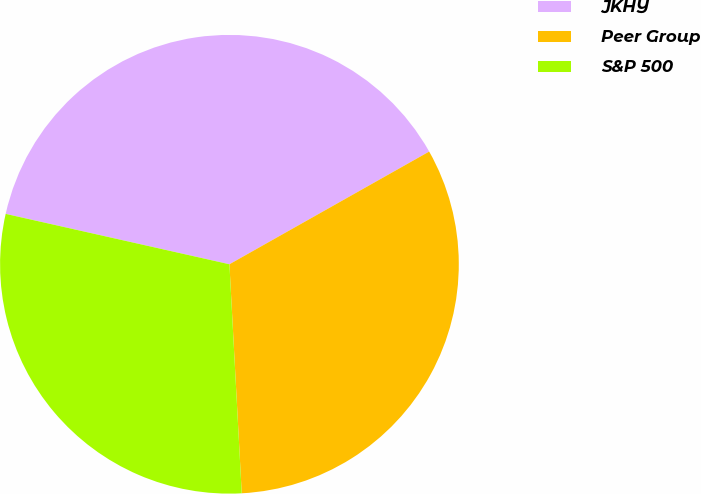Convert chart to OTSL. <chart><loc_0><loc_0><loc_500><loc_500><pie_chart><fcel>JKHY<fcel>Peer Group<fcel>S&P 500<nl><fcel>38.3%<fcel>32.32%<fcel>29.38%<nl></chart> 